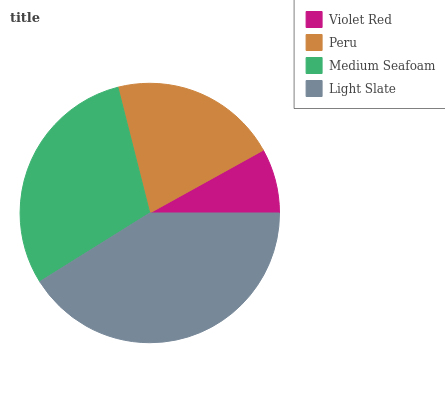Is Violet Red the minimum?
Answer yes or no. Yes. Is Light Slate the maximum?
Answer yes or no. Yes. Is Peru the minimum?
Answer yes or no. No. Is Peru the maximum?
Answer yes or no. No. Is Peru greater than Violet Red?
Answer yes or no. Yes. Is Violet Red less than Peru?
Answer yes or no. Yes. Is Violet Red greater than Peru?
Answer yes or no. No. Is Peru less than Violet Red?
Answer yes or no. No. Is Medium Seafoam the high median?
Answer yes or no. Yes. Is Peru the low median?
Answer yes or no. Yes. Is Violet Red the high median?
Answer yes or no. No. Is Medium Seafoam the low median?
Answer yes or no. No. 